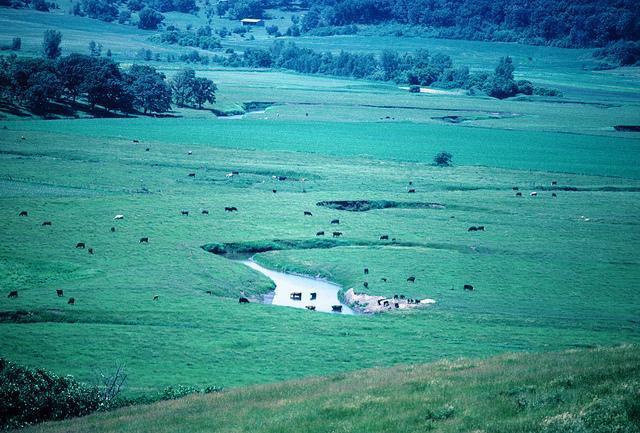How many Wii remotes are there?
Give a very brief answer. 0. 